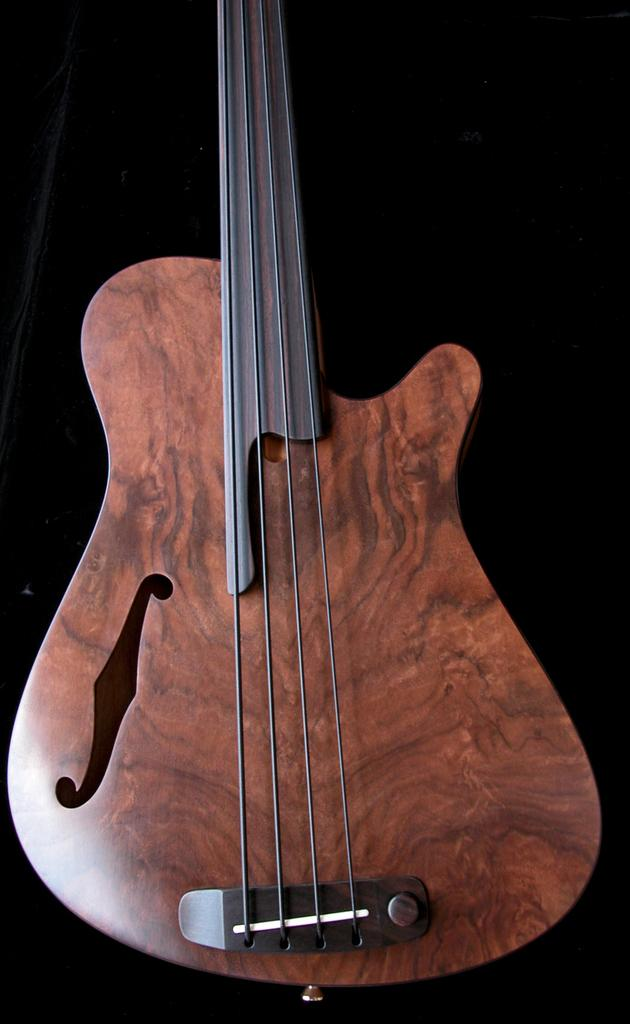What type of instrument is shown in the image? The image depicts a wooden guitar. What can be observed about the color of the guitar's background? The background of the guitar is in black color. What is the guitar's desire in the image? The guitar is an inanimate object and does not have desires. 